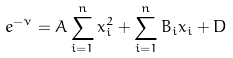Convert formula to latex. <formula><loc_0><loc_0><loc_500><loc_500>e ^ { - \nu } = A \sum _ { i = 1 } ^ { n } x _ { i } ^ { 2 } + \sum _ { i = 1 } ^ { n } B _ { i } x _ { i } + D</formula> 